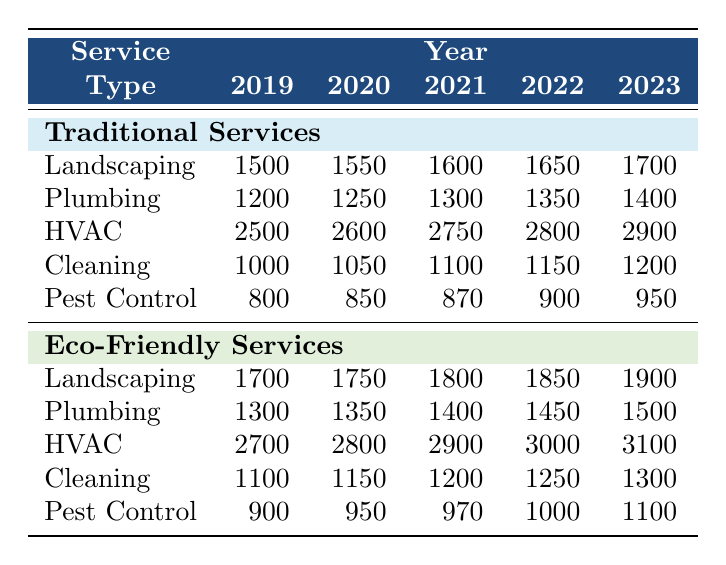What were the traditional service costs for HVAC in 2020? The table indicates that HVAC costs for traditional services in 2020 are listed as 2600.
Answer: 2600 In which year did landscaping services see the highest cost increase for eco-friendly options? By analyzing the eco-friendly landscape costs from 2019 to 2023, we can see the increases: 1700 to 1900. The highest increase happened from 2019 to 2020 (50) and from 2022 to 2023 (50). There were consistent increases each year, but it's the same amount.
Answer: 2020 and 2023 both had the highest increase of 50 Were eco-friendly cleaning services more expensive than traditional cleaning services in all years? By examining the table, in every recorded year from 2019 to 2023, eco-friendly cleaning costs are always higher than traditional cleaning costs.
Answer: Yes What is the total cost difference between traditional and eco-friendly pest control services in 2021? For 2021, traditional pest control costs are 870 and eco-friendly costs are 970. The difference is calculated as follows: 970 - 870 = 100.
Answer: 100 Which service type had the smallest cost increase for traditional services over the five years? Analyzing the data for traditional service costs from 2019 to 2023: Landscaping increases by 200, Plumbing by 200, HVAC by 400, Cleaning by 200, and Pest Control by 150. The smallest increase is for Pest Control which is 150.
Answer: Pest Control What was the average cost for eco-friendly services in 2022? The eco-friendly service costs for each type in 2022 are Landscaping 1850, Plumbing 1450, HVAC 3000, Cleaning 1250, Pest Control 1000. Summing these gives 1850 + 1450 + 3000 + 1250 + 1000 = 9550. Divided by the number of service types (5), gives an average of 1910.
Answer: 1910 How much did the HVAC service costs for traditional options increase from 2019 to 2023? The traditional HVAC costs were 2500 in 2019 and increased to 2900 in 2023. The increase is calculated as 2900 - 2500 = 400.
Answer: 400 Is the cost of plumbing services for eco-friendly options consistently increasing each year? By checking the plumbing costs for eco-friendly services from 2019 to 2023, the costs are 1300, 1350, 1400, 1450, and 1500. Each year shows a steady increase, confirming the trend.
Answer: Yes 